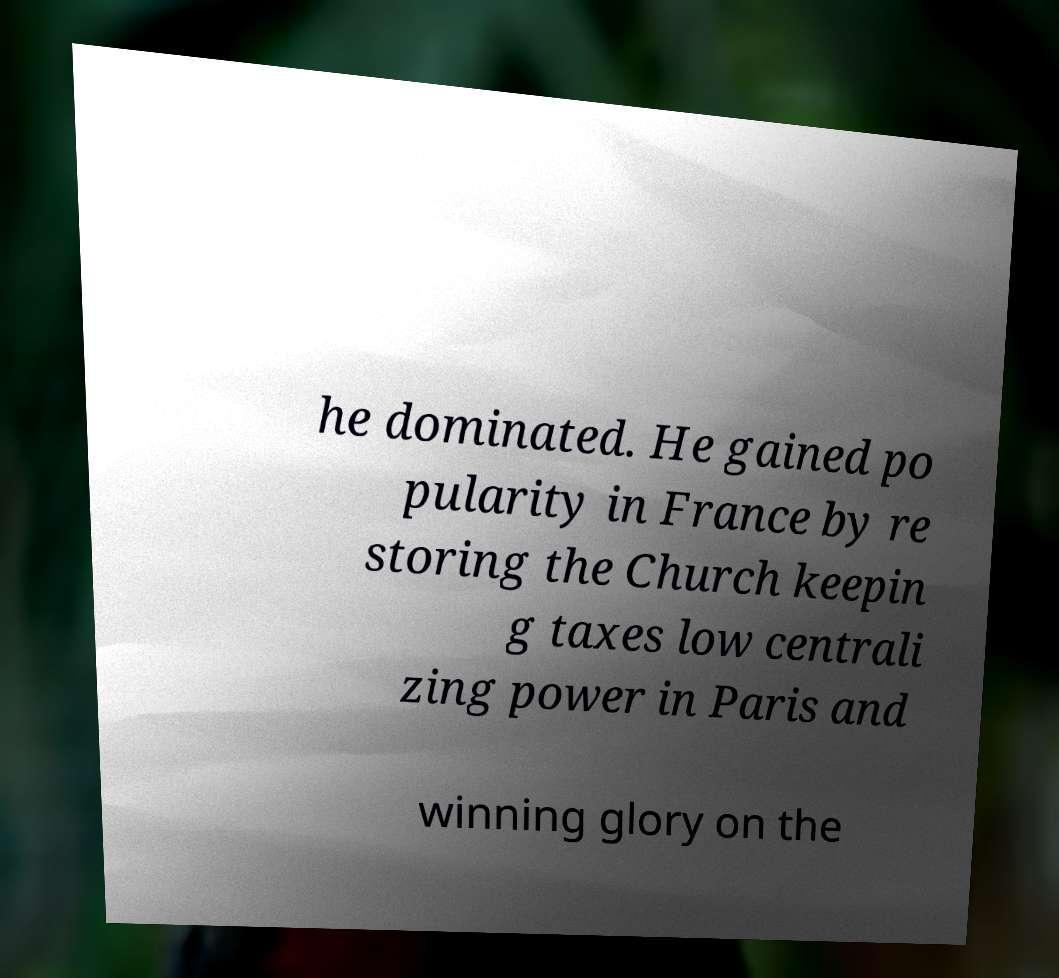Could you assist in decoding the text presented in this image and type it out clearly? he dominated. He gained po pularity in France by re storing the Church keepin g taxes low centrali zing power in Paris and winning glory on the 